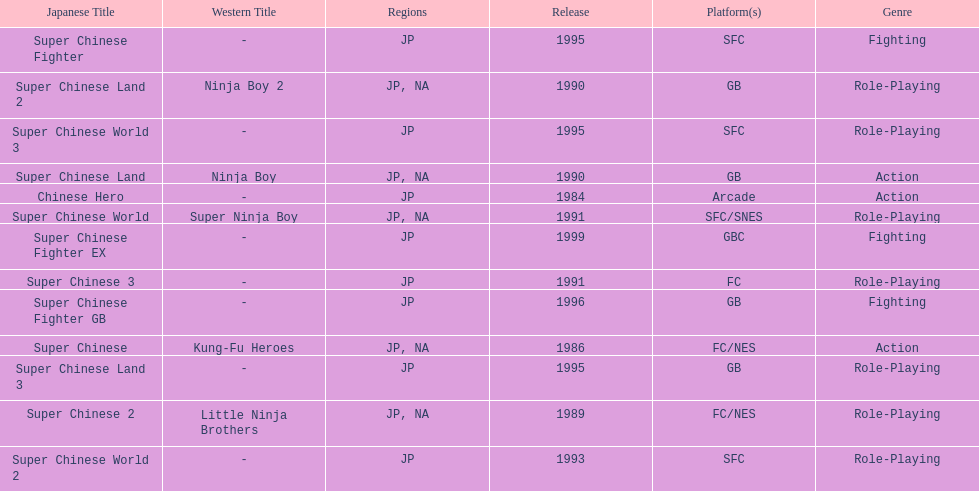Which platforms had the most titles released? GB. I'm looking to parse the entire table for insights. Could you assist me with that? {'header': ['Japanese Title', 'Western Title', 'Regions', 'Release', 'Platform(s)', 'Genre'], 'rows': [['Super Chinese Fighter', '-', 'JP', '1995', 'SFC', 'Fighting'], ['Super Chinese Land 2', 'Ninja Boy 2', 'JP, NA', '1990', 'GB', 'Role-Playing'], ['Super Chinese World 3', '-', 'JP', '1995', 'SFC', 'Role-Playing'], ['Super Chinese Land', 'Ninja Boy', 'JP, NA', '1990', 'GB', 'Action'], ['Chinese Hero', '-', 'JP', '1984', 'Arcade', 'Action'], ['Super Chinese World', 'Super Ninja Boy', 'JP, NA', '1991', 'SFC/SNES', 'Role-Playing'], ['Super Chinese Fighter EX', '-', 'JP', '1999', 'GBC', 'Fighting'], ['Super Chinese 3', '-', 'JP', '1991', 'FC', 'Role-Playing'], ['Super Chinese Fighter GB', '-', 'JP', '1996', 'GB', 'Fighting'], ['Super Chinese', 'Kung-Fu Heroes', 'JP, NA', '1986', 'FC/NES', 'Action'], ['Super Chinese Land 3', '-', 'JP', '1995', 'GB', 'Role-Playing'], ['Super Chinese 2', 'Little Ninja Brothers', 'JP, NA', '1989', 'FC/NES', 'Role-Playing'], ['Super Chinese World 2', '-', 'JP', '1993', 'SFC', 'Role-Playing']]} 